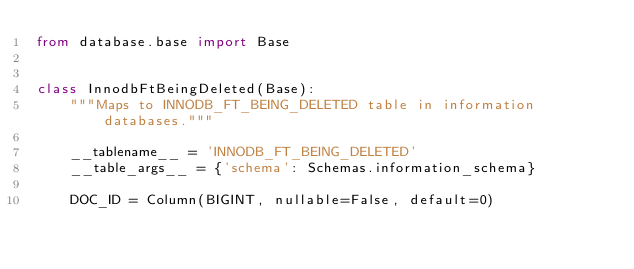Convert code to text. <code><loc_0><loc_0><loc_500><loc_500><_Python_>from database.base import Base


class InnodbFtBeingDeleted(Base):
    """Maps to INNODB_FT_BEING_DELETED table in information databases."""

    __tablename__ = 'INNODB_FT_BEING_DELETED'
    __table_args__ = {'schema': Schemas.information_schema}

    DOC_ID = Column(BIGINT, nullable=False, default=0)
</code> 